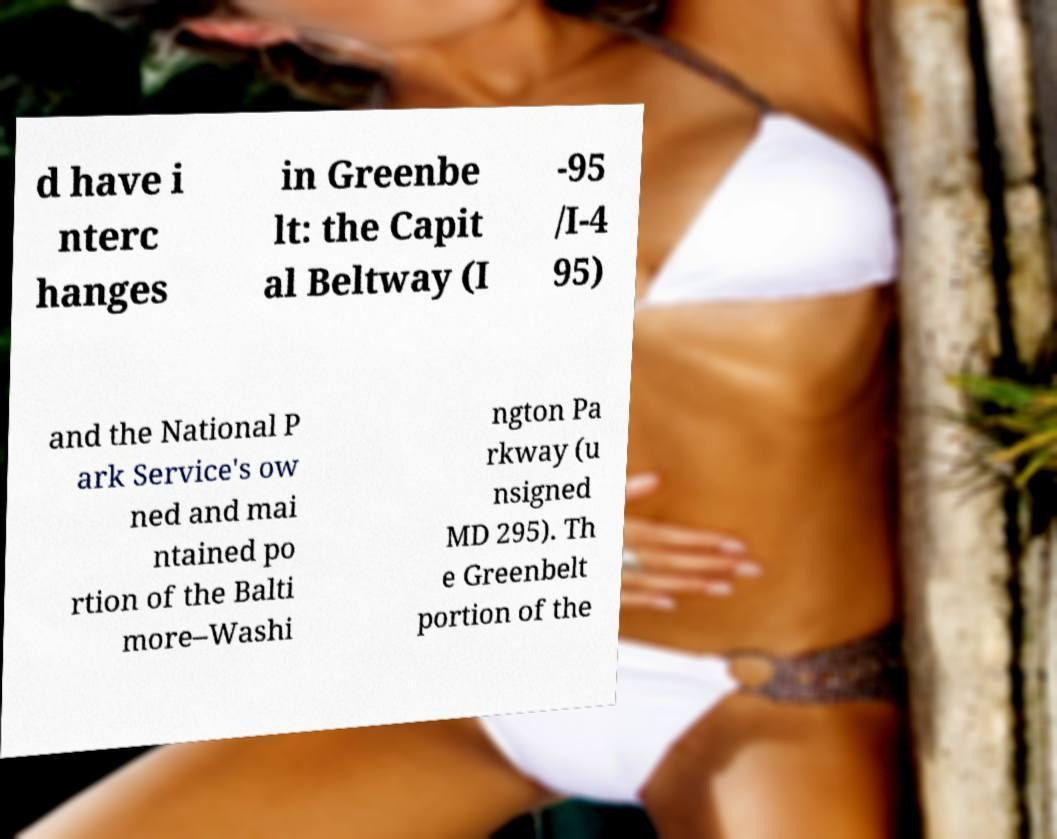Please read and relay the text visible in this image. What does it say? d have i nterc hanges in Greenbe lt: the Capit al Beltway (I -95 /I-4 95) and the National P ark Service's ow ned and mai ntained po rtion of the Balti more–Washi ngton Pa rkway (u nsigned MD 295). Th e Greenbelt portion of the 